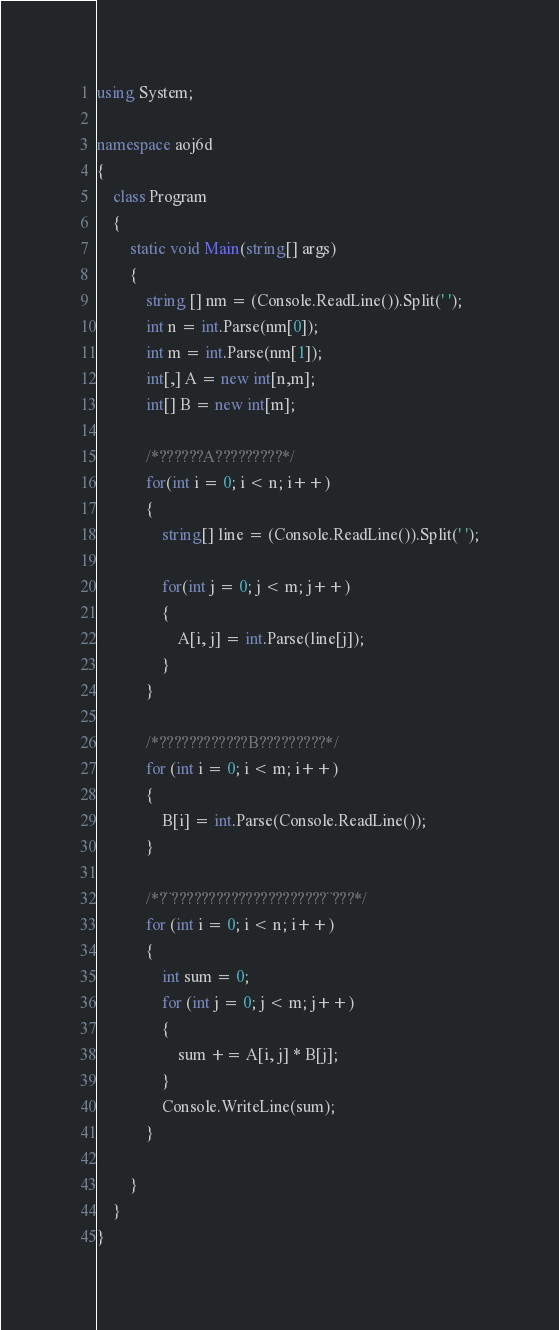<code> <loc_0><loc_0><loc_500><loc_500><_C#_>using System;

namespace aoj6d
{
    class Program
    {
        static void Main(string[] args)
        {
            string [] nm = (Console.ReadLine()).Split(' ');
            int n = int.Parse(nm[0]);
            int m = int.Parse(nm[1]);
            int[,] A = new int[n,m];
            int[] B = new int[m];

            /*??????A?????????*/
            for(int i = 0; i < n; i++)
            {
                string[] line = (Console.ReadLine()).Split(' ');

                for(int j = 0; j < m; j++)
                {
                    A[i, j] = int.Parse(line[j]); 
                }
            }

            /*????????????B?????????*/
            for (int i = 0; i < m; i++)
            {
                B[i] = int.Parse(Console.ReadLine());
            }

            /*?¨?????????????????????¨???*/
            for (int i = 0; i < n; i++)
            {
                int sum = 0;
                for (int j = 0; j < m; j++)
                {
                    sum += A[i, j] * B[j];
                }
                Console.WriteLine(sum);
            }

        }
    }
}</code> 